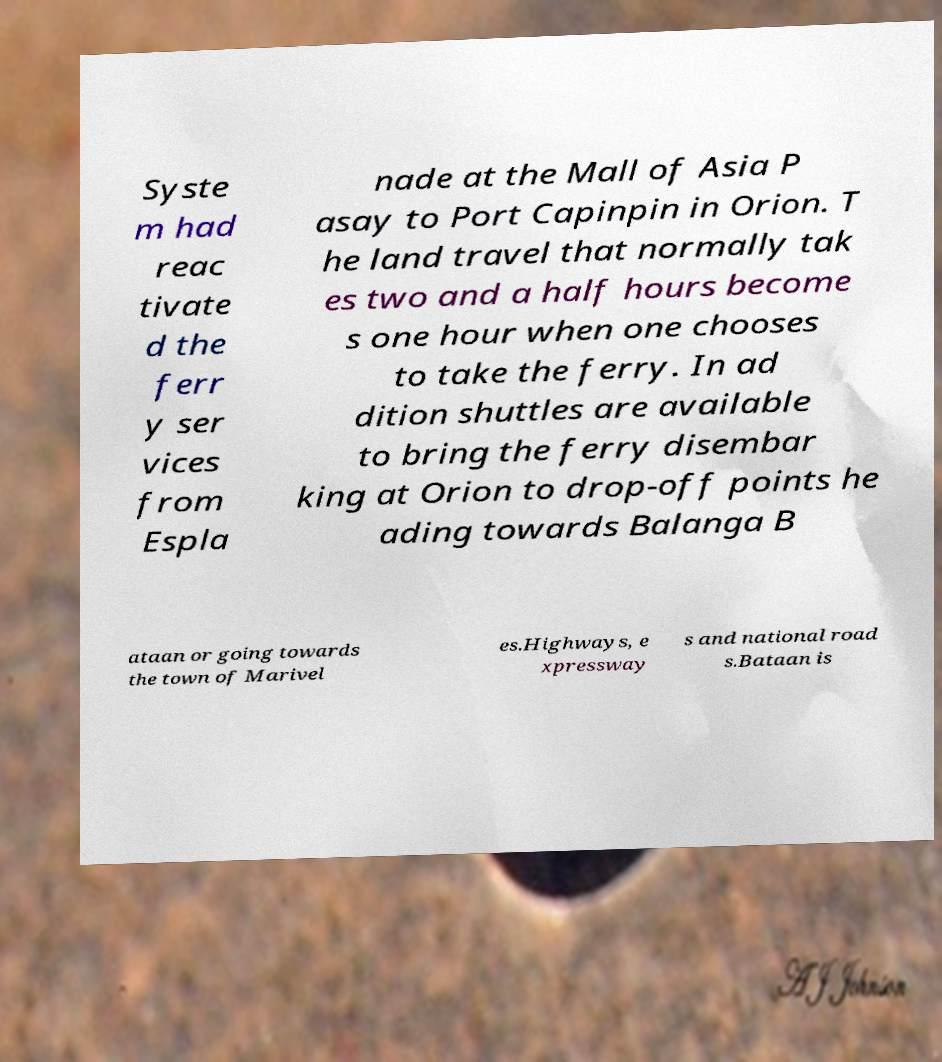What messages or text are displayed in this image? I need them in a readable, typed format. Syste m had reac tivate d the ferr y ser vices from Espla nade at the Mall of Asia P asay to Port Capinpin in Orion. T he land travel that normally tak es two and a half hours become s one hour when one chooses to take the ferry. In ad dition shuttles are available to bring the ferry disembar king at Orion to drop-off points he ading towards Balanga B ataan or going towards the town of Marivel es.Highways, e xpressway s and national road s.Bataan is 